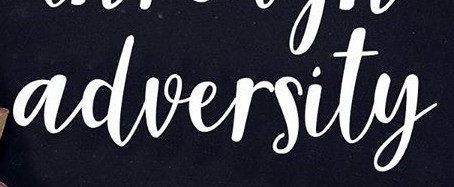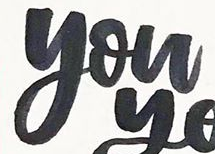Transcribe the words shown in these images in order, separated by a semicolon. adversity; you 